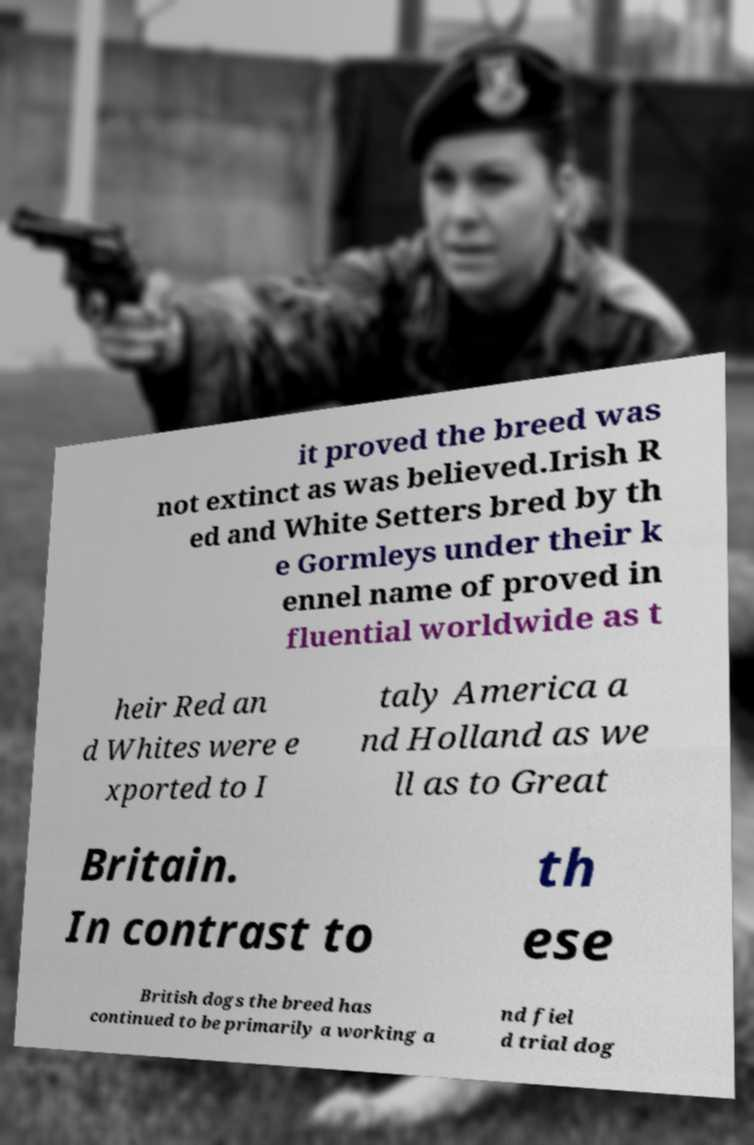What messages or text are displayed in this image? I need them in a readable, typed format. it proved the breed was not extinct as was believed.Irish R ed and White Setters bred by th e Gormleys under their k ennel name of proved in fluential worldwide as t heir Red an d Whites were e xported to I taly America a nd Holland as we ll as to Great Britain. In contrast to th ese British dogs the breed has continued to be primarily a working a nd fiel d trial dog 